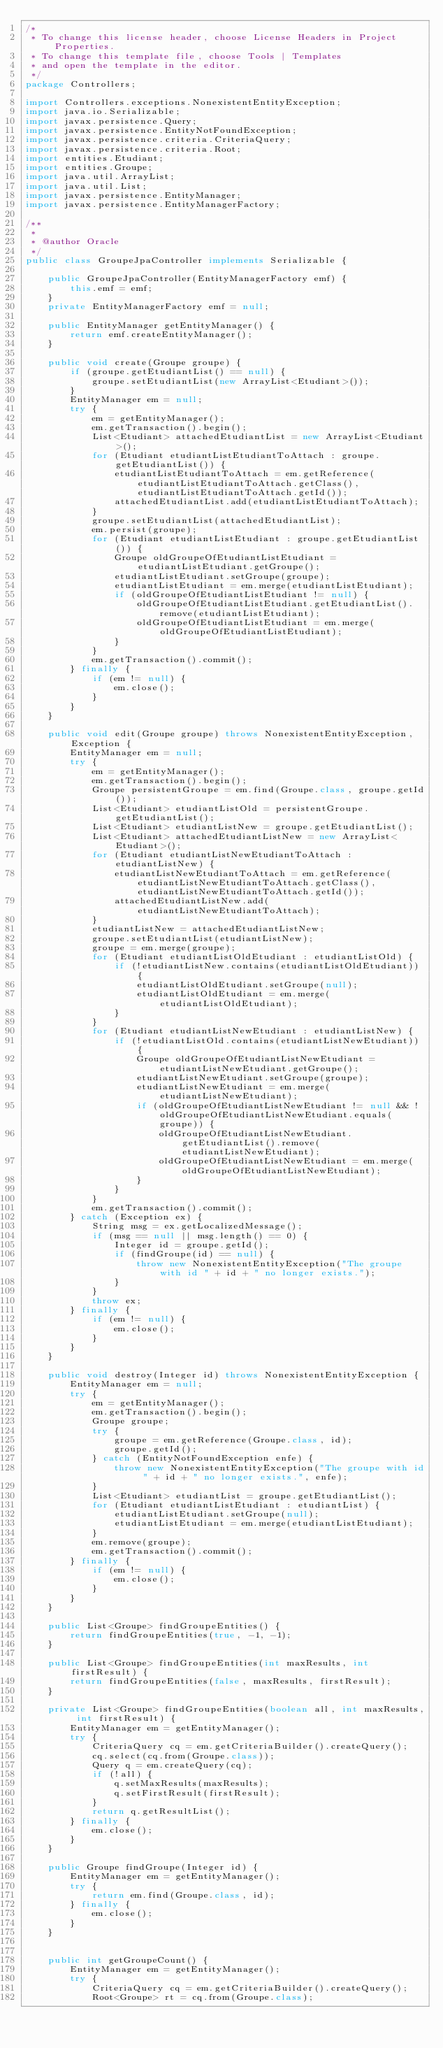Convert code to text. <code><loc_0><loc_0><loc_500><loc_500><_Java_>/*
 * To change this license header, choose License Headers in Project Properties.
 * To change this template file, choose Tools | Templates
 * and open the template in the editor.
 */
package Controllers;

import Controllers.exceptions.NonexistentEntityException;
import java.io.Serializable;
import javax.persistence.Query;
import javax.persistence.EntityNotFoundException;
import javax.persistence.criteria.CriteriaQuery;
import javax.persistence.criteria.Root;
import entities.Etudiant;
import entities.Groupe;
import java.util.ArrayList;
import java.util.List;
import javax.persistence.EntityManager;
import javax.persistence.EntityManagerFactory;

/**
 *
 * @author Oracle
 */
public class GroupeJpaController implements Serializable {

    public GroupeJpaController(EntityManagerFactory emf) {
        this.emf = emf;
    }
    private EntityManagerFactory emf = null;

    public EntityManager getEntityManager() {
        return emf.createEntityManager();
    }

    public void create(Groupe groupe) {
        if (groupe.getEtudiantList() == null) {
            groupe.setEtudiantList(new ArrayList<Etudiant>());
        }
        EntityManager em = null;
        try {
            em = getEntityManager();
            em.getTransaction().begin();
            List<Etudiant> attachedEtudiantList = new ArrayList<Etudiant>();
            for (Etudiant etudiantListEtudiantToAttach : groupe.getEtudiantList()) {
                etudiantListEtudiantToAttach = em.getReference(etudiantListEtudiantToAttach.getClass(), etudiantListEtudiantToAttach.getId());
                attachedEtudiantList.add(etudiantListEtudiantToAttach);
            }
            groupe.setEtudiantList(attachedEtudiantList);
            em.persist(groupe);
            for (Etudiant etudiantListEtudiant : groupe.getEtudiantList()) {
                Groupe oldGroupeOfEtudiantListEtudiant = etudiantListEtudiant.getGroupe();
                etudiantListEtudiant.setGroupe(groupe);
                etudiantListEtudiant = em.merge(etudiantListEtudiant);
                if (oldGroupeOfEtudiantListEtudiant != null) {
                    oldGroupeOfEtudiantListEtudiant.getEtudiantList().remove(etudiantListEtudiant);
                    oldGroupeOfEtudiantListEtudiant = em.merge(oldGroupeOfEtudiantListEtudiant);
                }
            }
            em.getTransaction().commit();
        } finally {
            if (em != null) {
                em.close();
            }
        }
    }

    public void edit(Groupe groupe) throws NonexistentEntityException, Exception {
        EntityManager em = null;
        try {
            em = getEntityManager();
            em.getTransaction().begin();
            Groupe persistentGroupe = em.find(Groupe.class, groupe.getId());
            List<Etudiant> etudiantListOld = persistentGroupe.getEtudiantList();
            List<Etudiant> etudiantListNew = groupe.getEtudiantList();
            List<Etudiant> attachedEtudiantListNew = new ArrayList<Etudiant>();
            for (Etudiant etudiantListNewEtudiantToAttach : etudiantListNew) {
                etudiantListNewEtudiantToAttach = em.getReference(etudiantListNewEtudiantToAttach.getClass(), etudiantListNewEtudiantToAttach.getId());
                attachedEtudiantListNew.add(etudiantListNewEtudiantToAttach);
            }
            etudiantListNew = attachedEtudiantListNew;
            groupe.setEtudiantList(etudiantListNew);
            groupe = em.merge(groupe);
            for (Etudiant etudiantListOldEtudiant : etudiantListOld) {
                if (!etudiantListNew.contains(etudiantListOldEtudiant)) {
                    etudiantListOldEtudiant.setGroupe(null);
                    etudiantListOldEtudiant = em.merge(etudiantListOldEtudiant);
                }
            }
            for (Etudiant etudiantListNewEtudiant : etudiantListNew) {
                if (!etudiantListOld.contains(etudiantListNewEtudiant)) {
                    Groupe oldGroupeOfEtudiantListNewEtudiant = etudiantListNewEtudiant.getGroupe();
                    etudiantListNewEtudiant.setGroupe(groupe);
                    etudiantListNewEtudiant = em.merge(etudiantListNewEtudiant);
                    if (oldGroupeOfEtudiantListNewEtudiant != null && !oldGroupeOfEtudiantListNewEtudiant.equals(groupe)) {
                        oldGroupeOfEtudiantListNewEtudiant.getEtudiantList().remove(etudiantListNewEtudiant);
                        oldGroupeOfEtudiantListNewEtudiant = em.merge(oldGroupeOfEtudiantListNewEtudiant);
                    }
                }
            }
            em.getTransaction().commit();
        } catch (Exception ex) {
            String msg = ex.getLocalizedMessage();
            if (msg == null || msg.length() == 0) {
                Integer id = groupe.getId();
                if (findGroupe(id) == null) {
                    throw new NonexistentEntityException("The groupe with id " + id + " no longer exists.");
                }
            }
            throw ex;
        } finally {
            if (em != null) {
                em.close();
            }
        }
    }

    public void destroy(Integer id) throws NonexistentEntityException {
        EntityManager em = null;
        try {
            em = getEntityManager();
            em.getTransaction().begin();
            Groupe groupe;
            try {
                groupe = em.getReference(Groupe.class, id);
                groupe.getId();
            } catch (EntityNotFoundException enfe) {
                throw new NonexistentEntityException("The groupe with id " + id + " no longer exists.", enfe);
            }
            List<Etudiant> etudiantList = groupe.getEtudiantList();
            for (Etudiant etudiantListEtudiant : etudiantList) {
                etudiantListEtudiant.setGroupe(null);
                etudiantListEtudiant = em.merge(etudiantListEtudiant);
            }
            em.remove(groupe);
            em.getTransaction().commit();
        } finally {
            if (em != null) {
                em.close();
            }
        }
    }

    public List<Groupe> findGroupeEntities() {
        return findGroupeEntities(true, -1, -1);
    }

    public List<Groupe> findGroupeEntities(int maxResults, int firstResult) {
        return findGroupeEntities(false, maxResults, firstResult);
    }

    private List<Groupe> findGroupeEntities(boolean all, int maxResults, int firstResult) {
        EntityManager em = getEntityManager();
        try {
            CriteriaQuery cq = em.getCriteriaBuilder().createQuery();
            cq.select(cq.from(Groupe.class));
            Query q = em.createQuery(cq);
            if (!all) {
                q.setMaxResults(maxResults);
                q.setFirstResult(firstResult);
            }
            return q.getResultList();
        } finally {
            em.close();
        }
    }

    public Groupe findGroupe(Integer id) {
        EntityManager em = getEntityManager();
        try {
            return em.find(Groupe.class, id);
        } finally {
            em.close();
        }
    }


    public int getGroupeCount() {
        EntityManager em = getEntityManager();
        try {
            CriteriaQuery cq = em.getCriteriaBuilder().createQuery();
            Root<Groupe> rt = cq.from(Groupe.class);</code> 